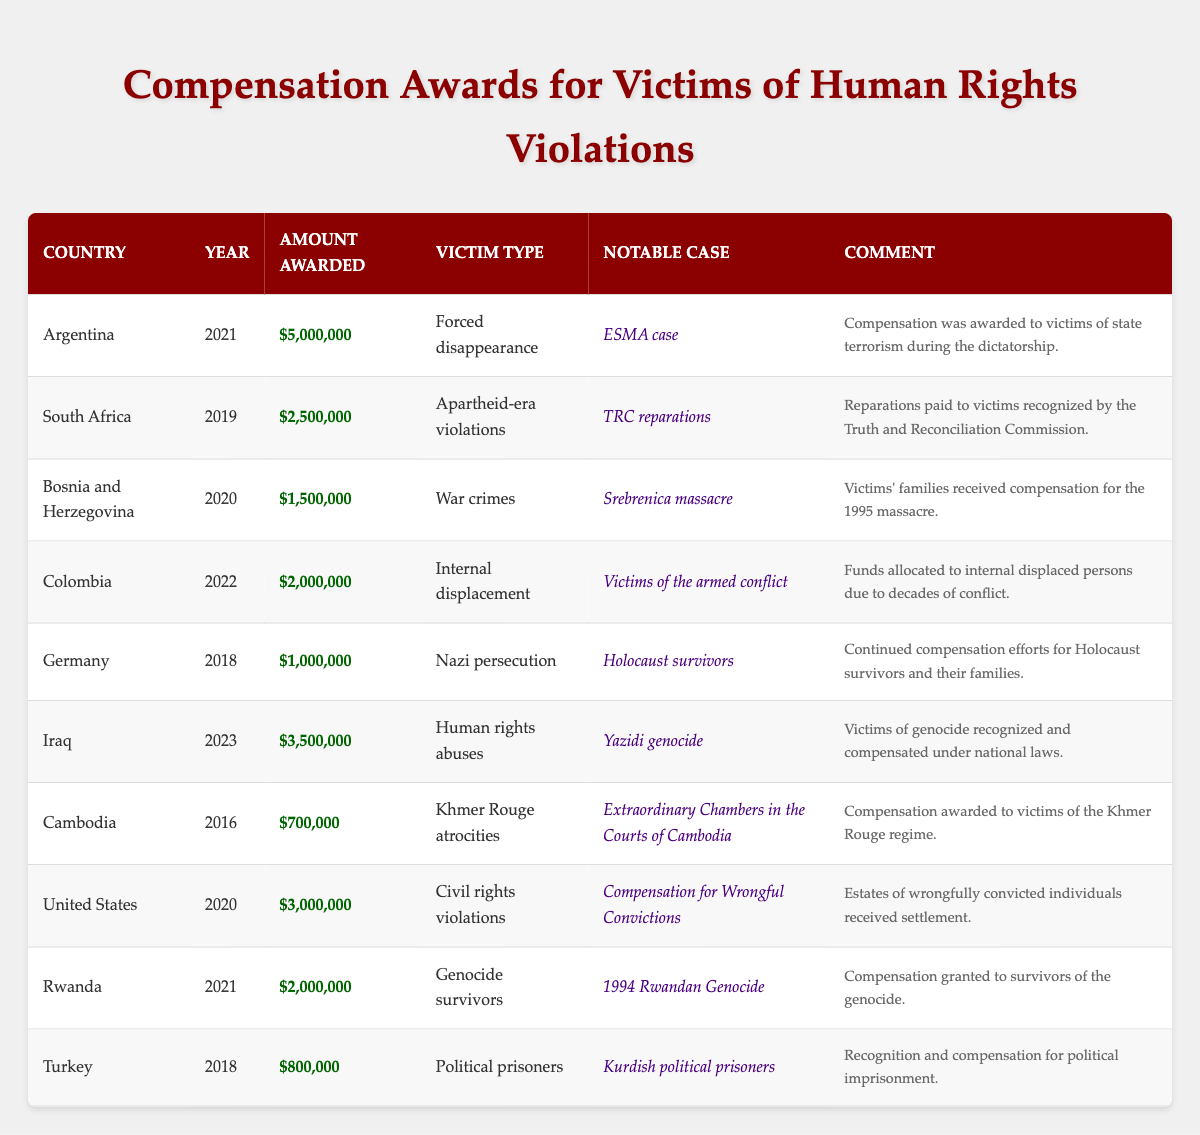What is the total amount awarded in Argentina for victims of forced disappearance? According to the table, Argentina awarded a total of $5,000,000 to victims of forced disappearance in 2021.
Answer: $5,000,000 Which country awarded compensation for genocide in 2023? The table indicates that Iraq awarded $3,500,000 for human rights abuses related to the Yazidi genocide in 2023.
Answer: Iraq How much was awarded to victims of the Srebrenica massacre? The table shows that Bosnia and Herzegovina awarded $1,500,000 to victims' families of the Srebrenica massacre in 2020.
Answer: $1,500,000 What is the total compensation awarded to victims in South Africa and Colombia combined? Combining South Africa's award of $2,500,000 in 2019 for apartheid-era violations and Colombia's award of $2,000,000 in 2022 for internal displacement gives a total of $2,500,000 + $2,000,000 = $4,500,000.
Answer: $4,500,000 Which country provided the lowest compensation amount, and how much was it? The lowest compensation amount in the table is $700,000 awarded to victims of Khmer Rouge atrocities in Cambodia in 2016.
Answer: $700,000 How many countries awarded more than $2,000,000 in compensation? The countries that awarded more than $2,000,000 are Argentina ($5,000,000), South Africa ($2,500,000), Iraq ($3,500,000), United States ($3,000,000), and Rwanda ($2,000,000), totaling 5 countries.
Answer: 5 Did Turkey award compensation for human rights abuses in 2018? The table shows Turkey awarded $800,000 in 2018, but it was for political prisoners, not explicitly for human rights abuses in general. Therefore, the statement is false.
Answer: No What range of compensation amounts were awarded in 2021? In 2021, Argentina awarded $5,000,000, and Rwanda awarded $2,000,000. Thus, the range is from $2,000,000 to $5,000,000, which is $5,000,000 - $2,000,000 = $3,000,000.
Answer: $3,000,000 How does the compensation awarded to Holocaust survivors compare to that for victims of the Yazidi genocide? The amount awarded to Holocaust survivors in Germany in 2018 was $1,000,000, which is less than the $3,500,000 awarded for the Yazidi genocide in Iraq in 2023. Thus, the comparison shows that the Yazidi genocide victims received a higher amount.
Answer: Yazidi genocide victims received more What was the purpose of the compensation awarded to victims in Cambodia? The compensation awarded in Cambodia was specifically for victims of Khmer Rouge atrocities as stated in the table.
Answer: For Khmer Rouge atrocities What is the average compensation amount for all countries listed in the table? To find the average, sum the awards: $5,000,000 + $2,500,000 + $1,500,000 + $2,000,000 + $1,000,000 + $3,500,000 + $700,000 + $3,000,000 + $2,000,000 + $800,000 = $22,000,000. There are 10 awards, so the average is $22,000,000 / 10 = $2,200,000.
Answer: $2,200,000 